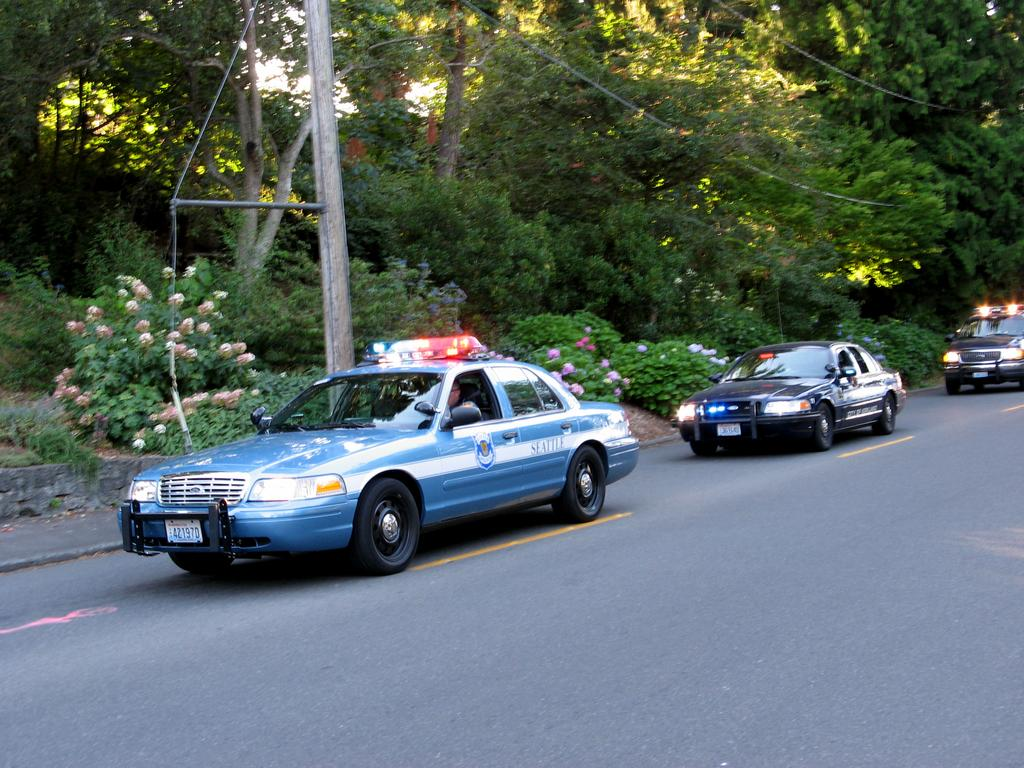What is located at the bottom of the image? There is a road at the bottom of the image. What types of objects can be seen on the road? There are vehicles in the image. What kind of vegetation is present in the image? There are plants with flowers and trees in the image. What is the closest object to the viewer in the foreground of the image? There is a pole in the foreground of the image. What type of zebra can be seen grazing on the flowers in the image? There is no zebra present in the image; it features plants with flowers and vehicles on a road. Can you tell me how many pencils are lying on the road in the image? There are no pencils visible on the road in the image. 